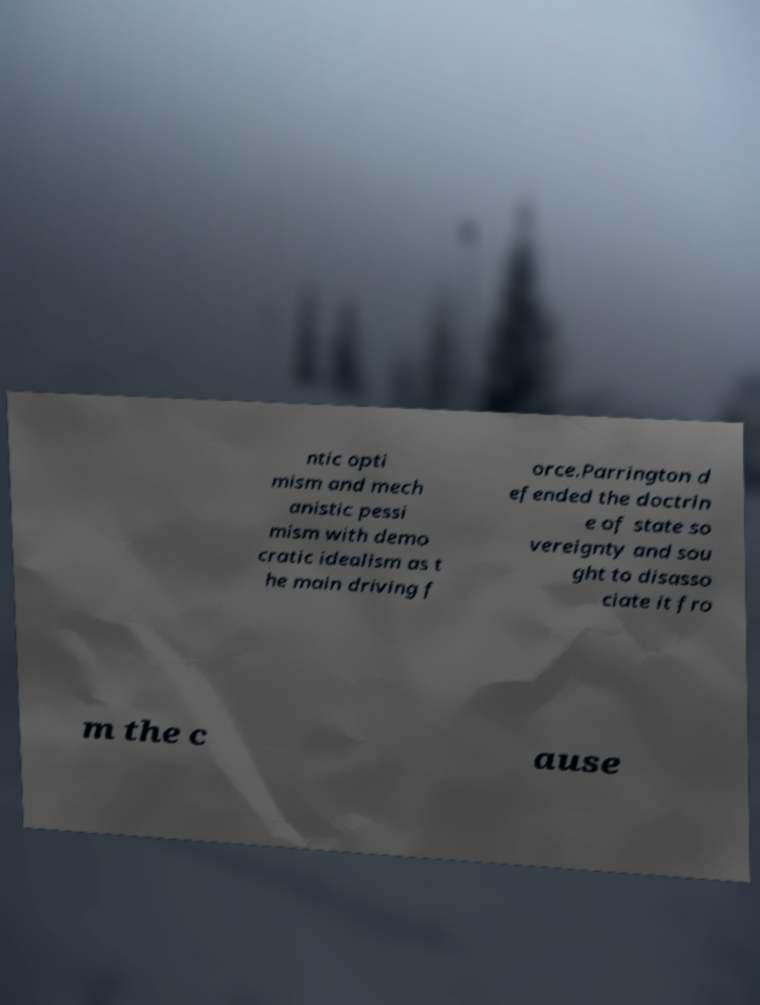Can you read and provide the text displayed in the image?This photo seems to have some interesting text. Can you extract and type it out for me? ntic opti mism and mech anistic pessi mism with demo cratic idealism as t he main driving f orce.Parrington d efended the doctrin e of state so vereignty and sou ght to disasso ciate it fro m the c ause 